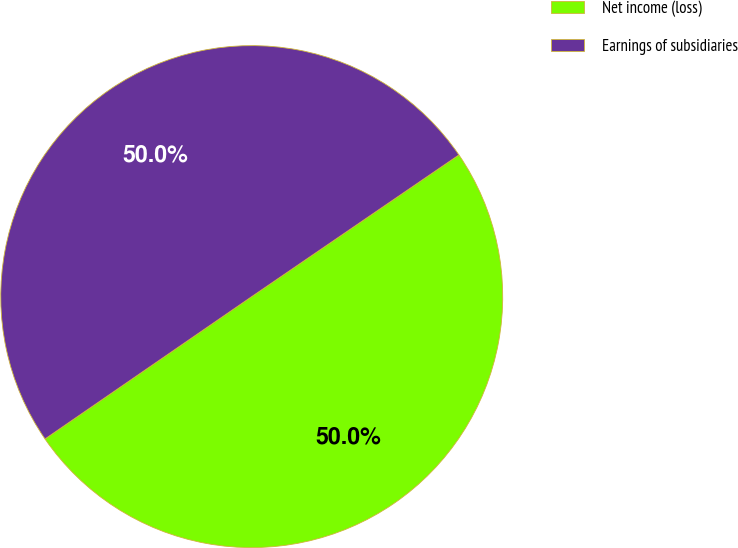Convert chart. <chart><loc_0><loc_0><loc_500><loc_500><pie_chart><fcel>Net income (loss)<fcel>Earnings of subsidiaries<nl><fcel>49.95%<fcel>50.05%<nl></chart> 